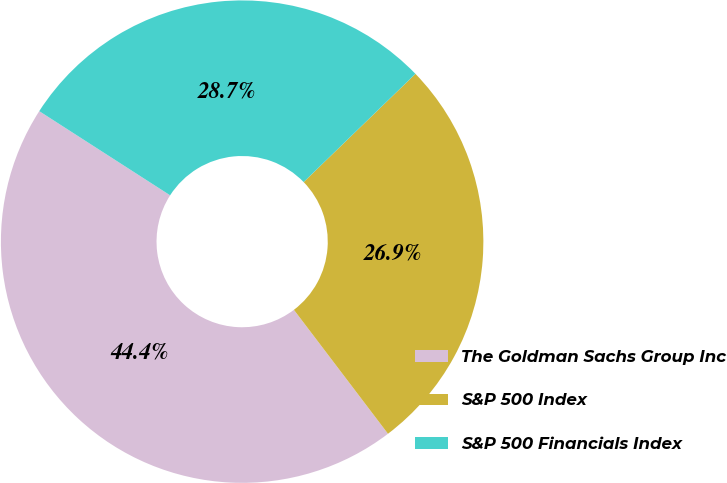Convert chart to OTSL. <chart><loc_0><loc_0><loc_500><loc_500><pie_chart><fcel>The Goldman Sachs Group Inc<fcel>S&P 500 Index<fcel>S&P 500 Financials Index<nl><fcel>44.43%<fcel>26.91%<fcel>28.66%<nl></chart> 